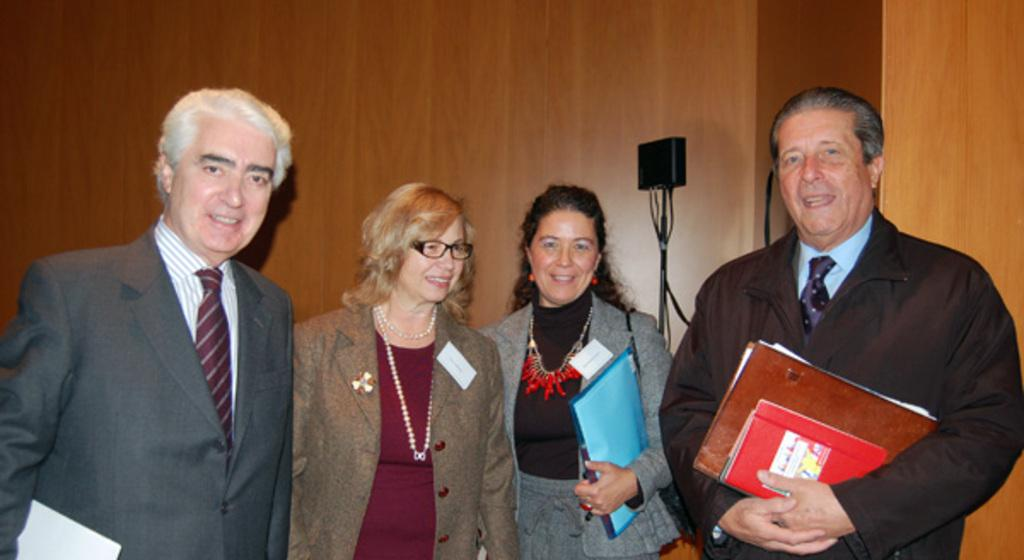How many people are in the foreground of the picture? There are four people in the foreground of the picture, two men and two women. What can be seen in the background of the picture? There is a mic and a well in the background of the picture. What type of pest can be seen crawling on the mic in the background? There are no pests visible in the image, and the mic is not being crawled on by any insects. 